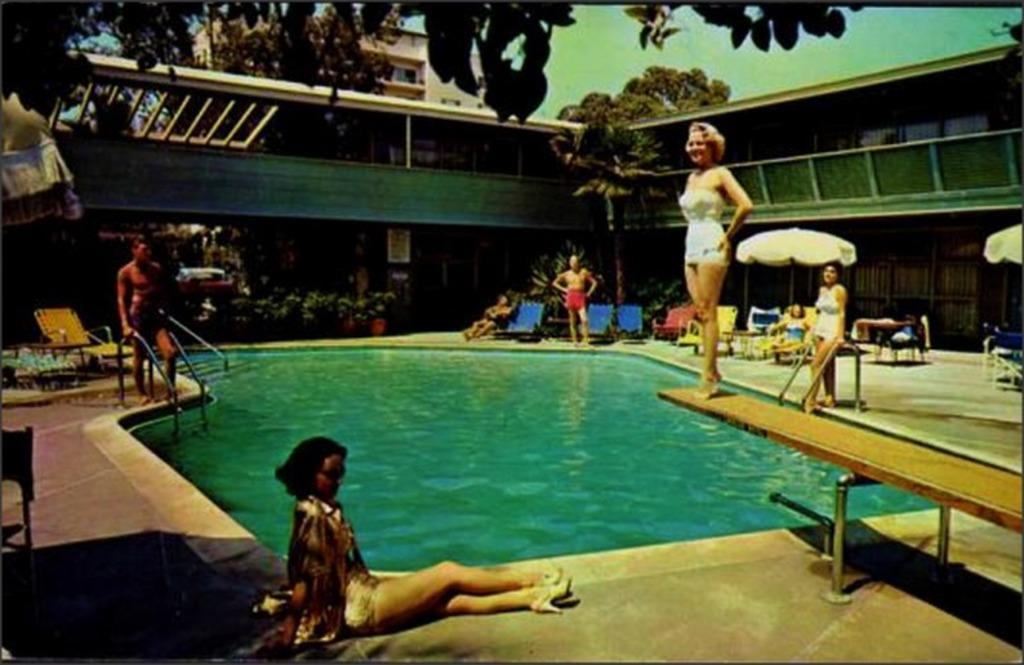Can you describe this image briefly? In this image we can see this person is sitting on the ground, this person is standing on the wooden plank and these people are standing on the ground. Here we can see chairs, swimming pool, trees, flower pots, buildings, umbrellas and sky in the background. 